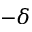Convert formula to latex. <formula><loc_0><loc_0><loc_500><loc_500>- \delta</formula> 